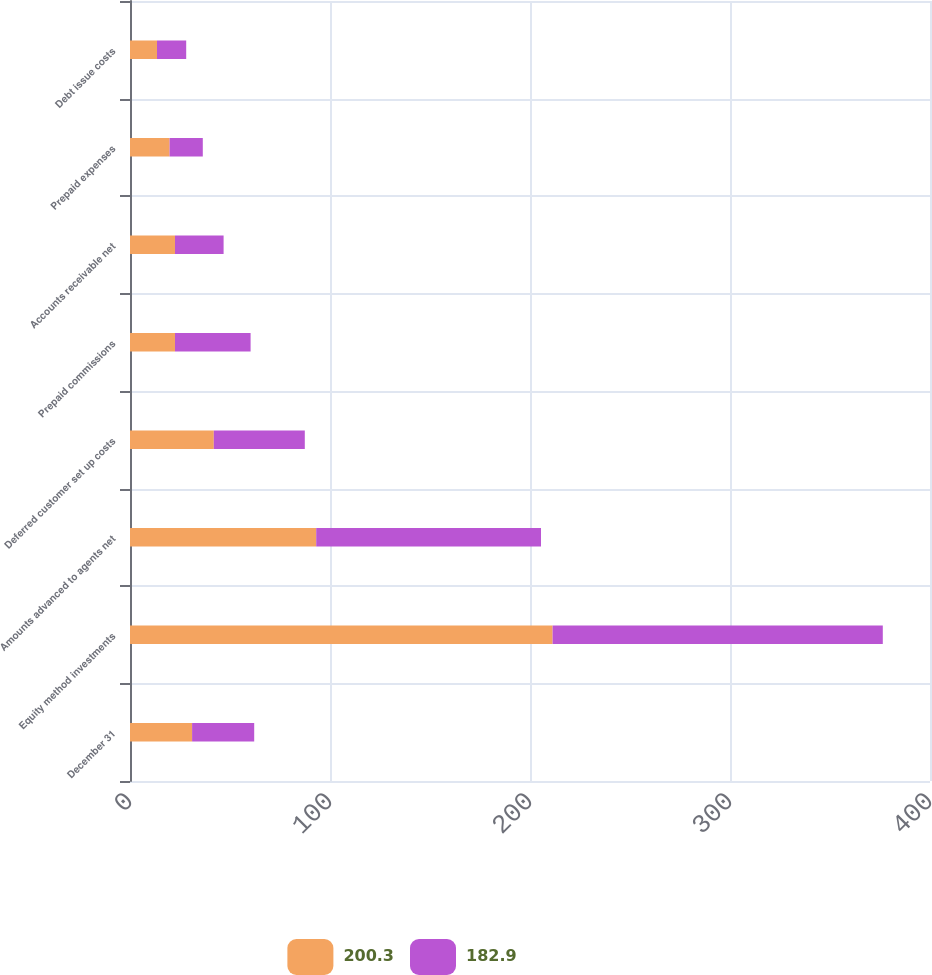Convert chart. <chart><loc_0><loc_0><loc_500><loc_500><stacked_bar_chart><ecel><fcel>December 31<fcel>Equity method investments<fcel>Amounts advanced to agents net<fcel>Deferred customer set up costs<fcel>Prepaid commissions<fcel>Accounts receivable net<fcel>Prepaid expenses<fcel>Debt issue costs<nl><fcel>200.3<fcel>31.05<fcel>211.3<fcel>93.1<fcel>41.9<fcel>22.5<fcel>22.5<fcel>19.8<fcel>13.5<nl><fcel>182.9<fcel>31.05<fcel>165.1<fcel>112.4<fcel>45.5<fcel>37.8<fcel>24.3<fcel>16.6<fcel>14.6<nl></chart> 